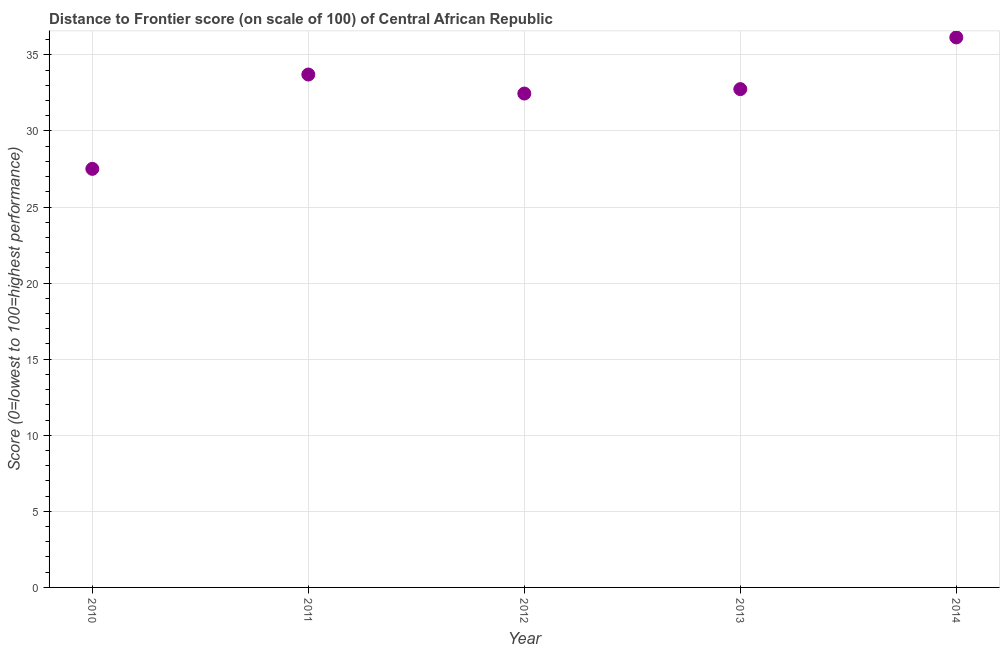What is the distance to frontier score in 2012?
Offer a very short reply. 32.46. Across all years, what is the maximum distance to frontier score?
Give a very brief answer. 36.15. Across all years, what is the minimum distance to frontier score?
Your answer should be very brief. 27.51. In which year was the distance to frontier score maximum?
Give a very brief answer. 2014. What is the sum of the distance to frontier score?
Your response must be concise. 162.58. What is the difference between the distance to frontier score in 2013 and 2014?
Make the answer very short. -3.4. What is the average distance to frontier score per year?
Your answer should be compact. 32.52. What is the median distance to frontier score?
Give a very brief answer. 32.75. What is the ratio of the distance to frontier score in 2011 to that in 2014?
Offer a very short reply. 0.93. Is the difference between the distance to frontier score in 2012 and 2013 greater than the difference between any two years?
Provide a succinct answer. No. What is the difference between the highest and the second highest distance to frontier score?
Offer a terse response. 2.44. Is the sum of the distance to frontier score in 2012 and 2014 greater than the maximum distance to frontier score across all years?
Your answer should be very brief. Yes. What is the difference between the highest and the lowest distance to frontier score?
Keep it short and to the point. 8.64. In how many years, is the distance to frontier score greater than the average distance to frontier score taken over all years?
Your answer should be very brief. 3. Does the distance to frontier score monotonically increase over the years?
Your response must be concise. No. Are the values on the major ticks of Y-axis written in scientific E-notation?
Offer a terse response. No. What is the title of the graph?
Offer a terse response. Distance to Frontier score (on scale of 100) of Central African Republic. What is the label or title of the Y-axis?
Provide a succinct answer. Score (0=lowest to 100=highest performance). What is the Score (0=lowest to 100=highest performance) in 2010?
Provide a succinct answer. 27.51. What is the Score (0=lowest to 100=highest performance) in 2011?
Ensure brevity in your answer.  33.71. What is the Score (0=lowest to 100=highest performance) in 2012?
Offer a very short reply. 32.46. What is the Score (0=lowest to 100=highest performance) in 2013?
Your answer should be compact. 32.75. What is the Score (0=lowest to 100=highest performance) in 2014?
Your answer should be compact. 36.15. What is the difference between the Score (0=lowest to 100=highest performance) in 2010 and 2012?
Your response must be concise. -4.95. What is the difference between the Score (0=lowest to 100=highest performance) in 2010 and 2013?
Your answer should be compact. -5.24. What is the difference between the Score (0=lowest to 100=highest performance) in 2010 and 2014?
Give a very brief answer. -8.64. What is the difference between the Score (0=lowest to 100=highest performance) in 2011 and 2012?
Your answer should be very brief. 1.25. What is the difference between the Score (0=lowest to 100=highest performance) in 2011 and 2014?
Offer a very short reply. -2.44. What is the difference between the Score (0=lowest to 100=highest performance) in 2012 and 2013?
Give a very brief answer. -0.29. What is the difference between the Score (0=lowest to 100=highest performance) in 2012 and 2014?
Your answer should be very brief. -3.69. What is the difference between the Score (0=lowest to 100=highest performance) in 2013 and 2014?
Your answer should be compact. -3.4. What is the ratio of the Score (0=lowest to 100=highest performance) in 2010 to that in 2011?
Offer a terse response. 0.82. What is the ratio of the Score (0=lowest to 100=highest performance) in 2010 to that in 2012?
Your response must be concise. 0.85. What is the ratio of the Score (0=lowest to 100=highest performance) in 2010 to that in 2013?
Offer a very short reply. 0.84. What is the ratio of the Score (0=lowest to 100=highest performance) in 2010 to that in 2014?
Provide a succinct answer. 0.76. What is the ratio of the Score (0=lowest to 100=highest performance) in 2011 to that in 2012?
Keep it short and to the point. 1.04. What is the ratio of the Score (0=lowest to 100=highest performance) in 2011 to that in 2014?
Your answer should be very brief. 0.93. What is the ratio of the Score (0=lowest to 100=highest performance) in 2012 to that in 2014?
Provide a short and direct response. 0.9. What is the ratio of the Score (0=lowest to 100=highest performance) in 2013 to that in 2014?
Your answer should be compact. 0.91. 